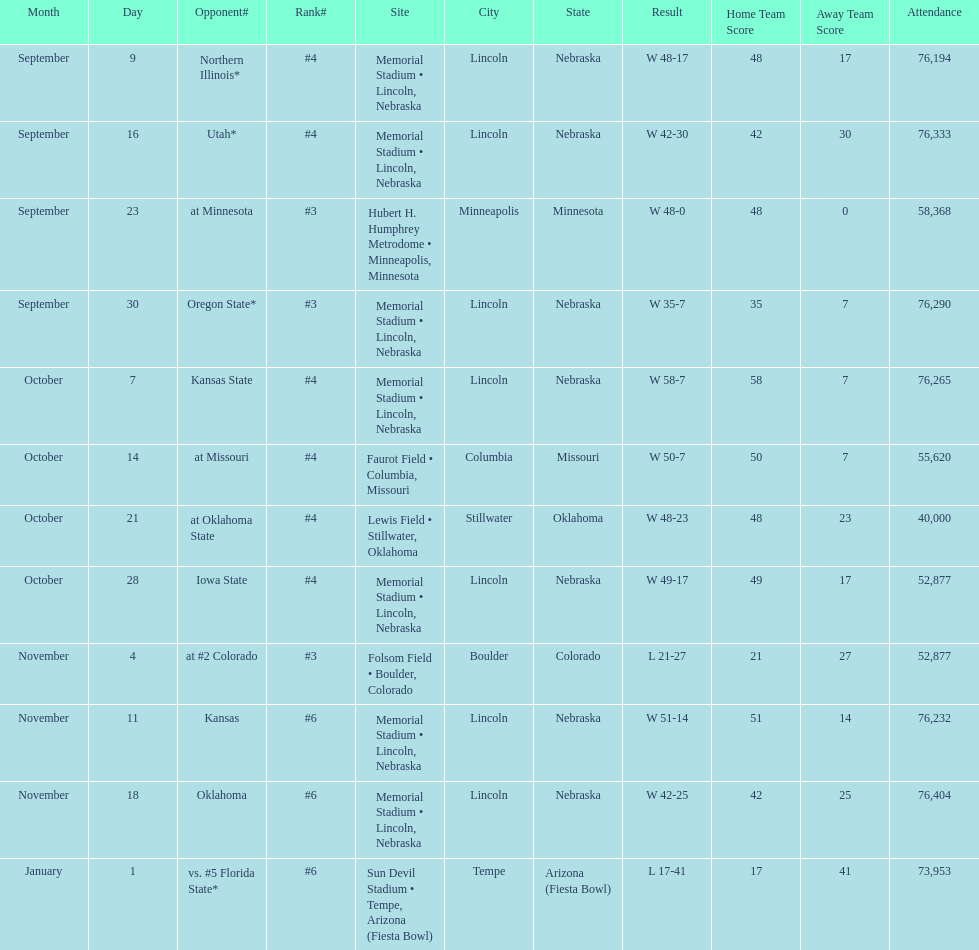Would you mind parsing the complete table? {'header': ['Month', 'Day', 'Opponent#', 'Rank#', 'Site', 'City', 'State', 'Result', 'Home Team Score', 'Away Team Score', 'Attendance'], 'rows': [['September', '9', 'Northern Illinois*', '#4', 'Memorial Stadium • Lincoln, Nebraska', 'Lincoln', 'Nebraska', 'W\xa048-17', '48', '17', '76,194'], ['September', '16', 'Utah*', '#4', 'Memorial Stadium • Lincoln, Nebraska', 'Lincoln', 'Nebraska', 'W\xa042-30', '42', '30', '76,333'], ['September', '23', 'at\xa0Minnesota', '#3', 'Hubert H. Humphrey Metrodome • Minneapolis, Minnesota', 'Minneapolis', 'Minnesota', 'W\xa048-0', '48', '0', '58,368'], ['September', '30', 'Oregon State*', '#3', 'Memorial Stadium • Lincoln, Nebraska', 'Lincoln', 'Nebraska', 'W\xa035-7', '35', '7', '76,290'], ['October', '7', 'Kansas State', '#4', 'Memorial Stadium • Lincoln, Nebraska', 'Lincoln', 'Nebraska', 'W\xa058-7', '58', '7', '76,265'], ['October', '14', 'at\xa0Missouri', '#4', 'Faurot Field • Columbia, Missouri', 'Columbia', 'Missouri', 'W\xa050-7', '50', '7', '55,620'], ['October', '21', 'at\xa0Oklahoma State', '#4', 'Lewis Field • Stillwater, Oklahoma', 'Stillwater', 'Oklahoma', 'W\xa048-23', '48', '23', '40,000'], ['October', '28', 'Iowa State', '#4', 'Memorial Stadium • Lincoln, Nebraska', 'Lincoln', 'Nebraska', 'W\xa049-17', '49', '17', '52,877'], ['November', '4', 'at\xa0#2\xa0Colorado', '#3', 'Folsom Field • Boulder, Colorado', 'Boulder', 'Colorado', 'L\xa021-27', '21', '27', '52,877'], ['November', '11', 'Kansas', '#6', 'Memorial Stadium • Lincoln, Nebraska', 'Lincoln', 'Nebraska', 'W\xa051-14', '51', '14', '76,232'], ['November', '18', 'Oklahoma', '#6', 'Memorial Stadium • Lincoln, Nebraska', 'Lincoln', 'Nebraska', 'W\xa042-25', '42', '25', '76,404'], ['January', '1', 'vs.\xa0#5\xa0Florida State*', '#6', 'Sun Devil Stadium • Tempe, Arizona (Fiesta Bowl)', 'Tempe', 'Arizona (Fiesta Bowl)', 'L\xa017-41', '17', '41', '73,953']]} What site at most is taken place? Memorial Stadium • Lincoln, Nebraska. 